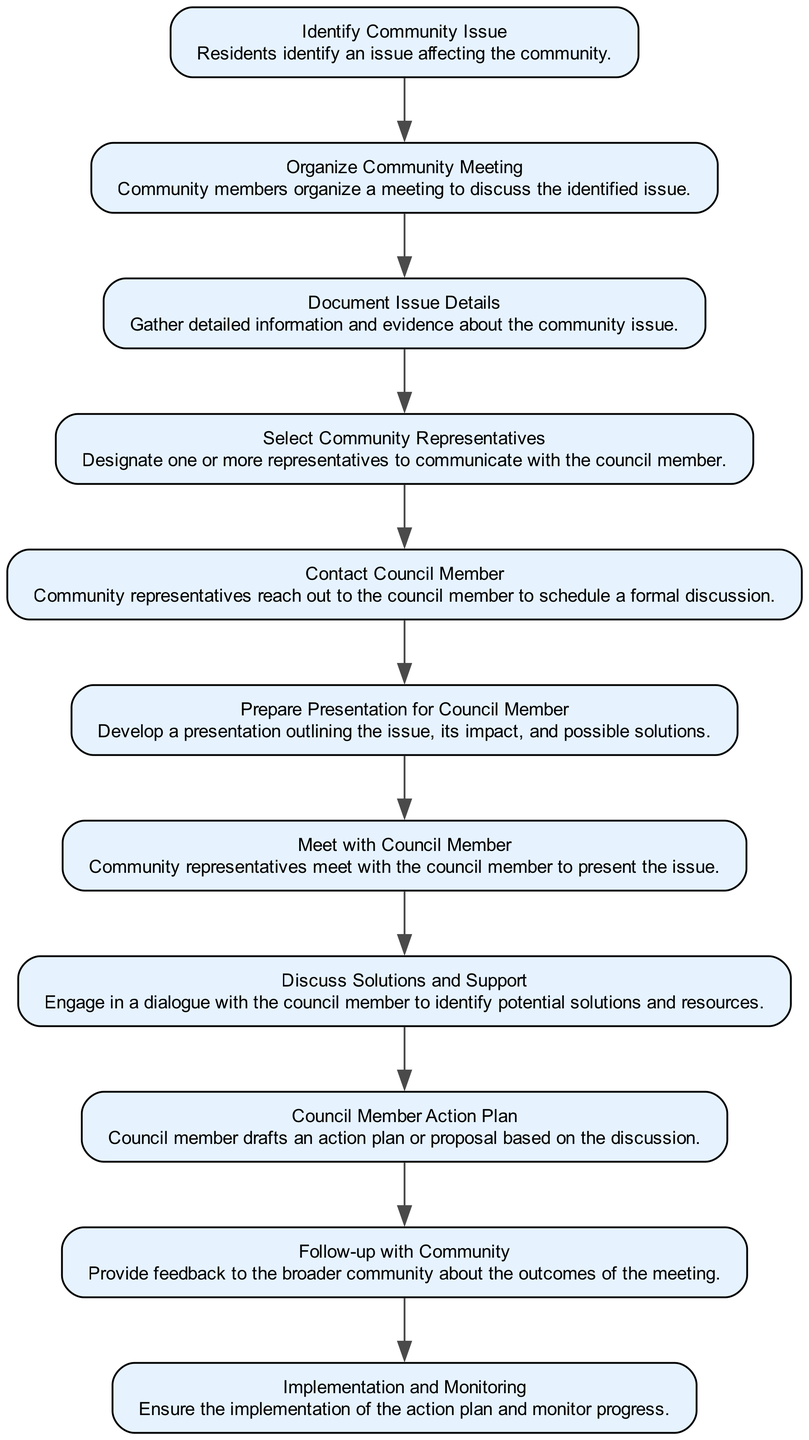What's the first step in the process? The first step identified in the flow chart is "Identify Community Issue." This is the starting point where residents recognize an issue affecting the community.
Answer: Identify Community Issue How many steps are there in total? By counting each node listed in the flow chart, there are a total of 11 steps in the community issue escalation process.
Answer: 11 What comes after "Organize Community Meeting"? The step that follows "Organize Community Meeting" is "Document Issue Details." This indicates that after organizing a meeting, the next action is to gather detailed information and evidence about the issue.
Answer: Document Issue Details Which step involves engaging in dialogue with the council member? The step that includes engaging in dialogue with the council member is "Discuss Solutions and Support." This reflects the interaction focused on potential solutions and resources.
Answer: Discuss Solutions and Support What is the final step in the process? The final step outlined in the flow chart is "Implementation and Monitoring." This step emphasizes the importance of ensuring that the action plan is implemented effectively and monitored for progress.
Answer: Implementation and Monitoring What is the relationship between "Contact Council Member" and "Meet with Council Member"? "Contact Council Member" is the step that leads into "Meet with Council Member." It implies that after reaching out, the community representatives then meet to present the issue.
Answer: Contact Council Member leads to Meet with Council Member How does the process ensure feedback to the community? The step "Follow-up with Community" is specifically designed to provide feedback to the broader community about the outcomes of the meeting, ensuring they are informed of the progress made.
Answer: Follow-up with Community What step follows “Prepare Presentation for Council Member”? The step that comes after "Prepare Presentation for Council Member" is "Meet with Council Member." This indicates that the preparation leads directly to a formal meeting with the council member.
Answer: Meet with Council Member 